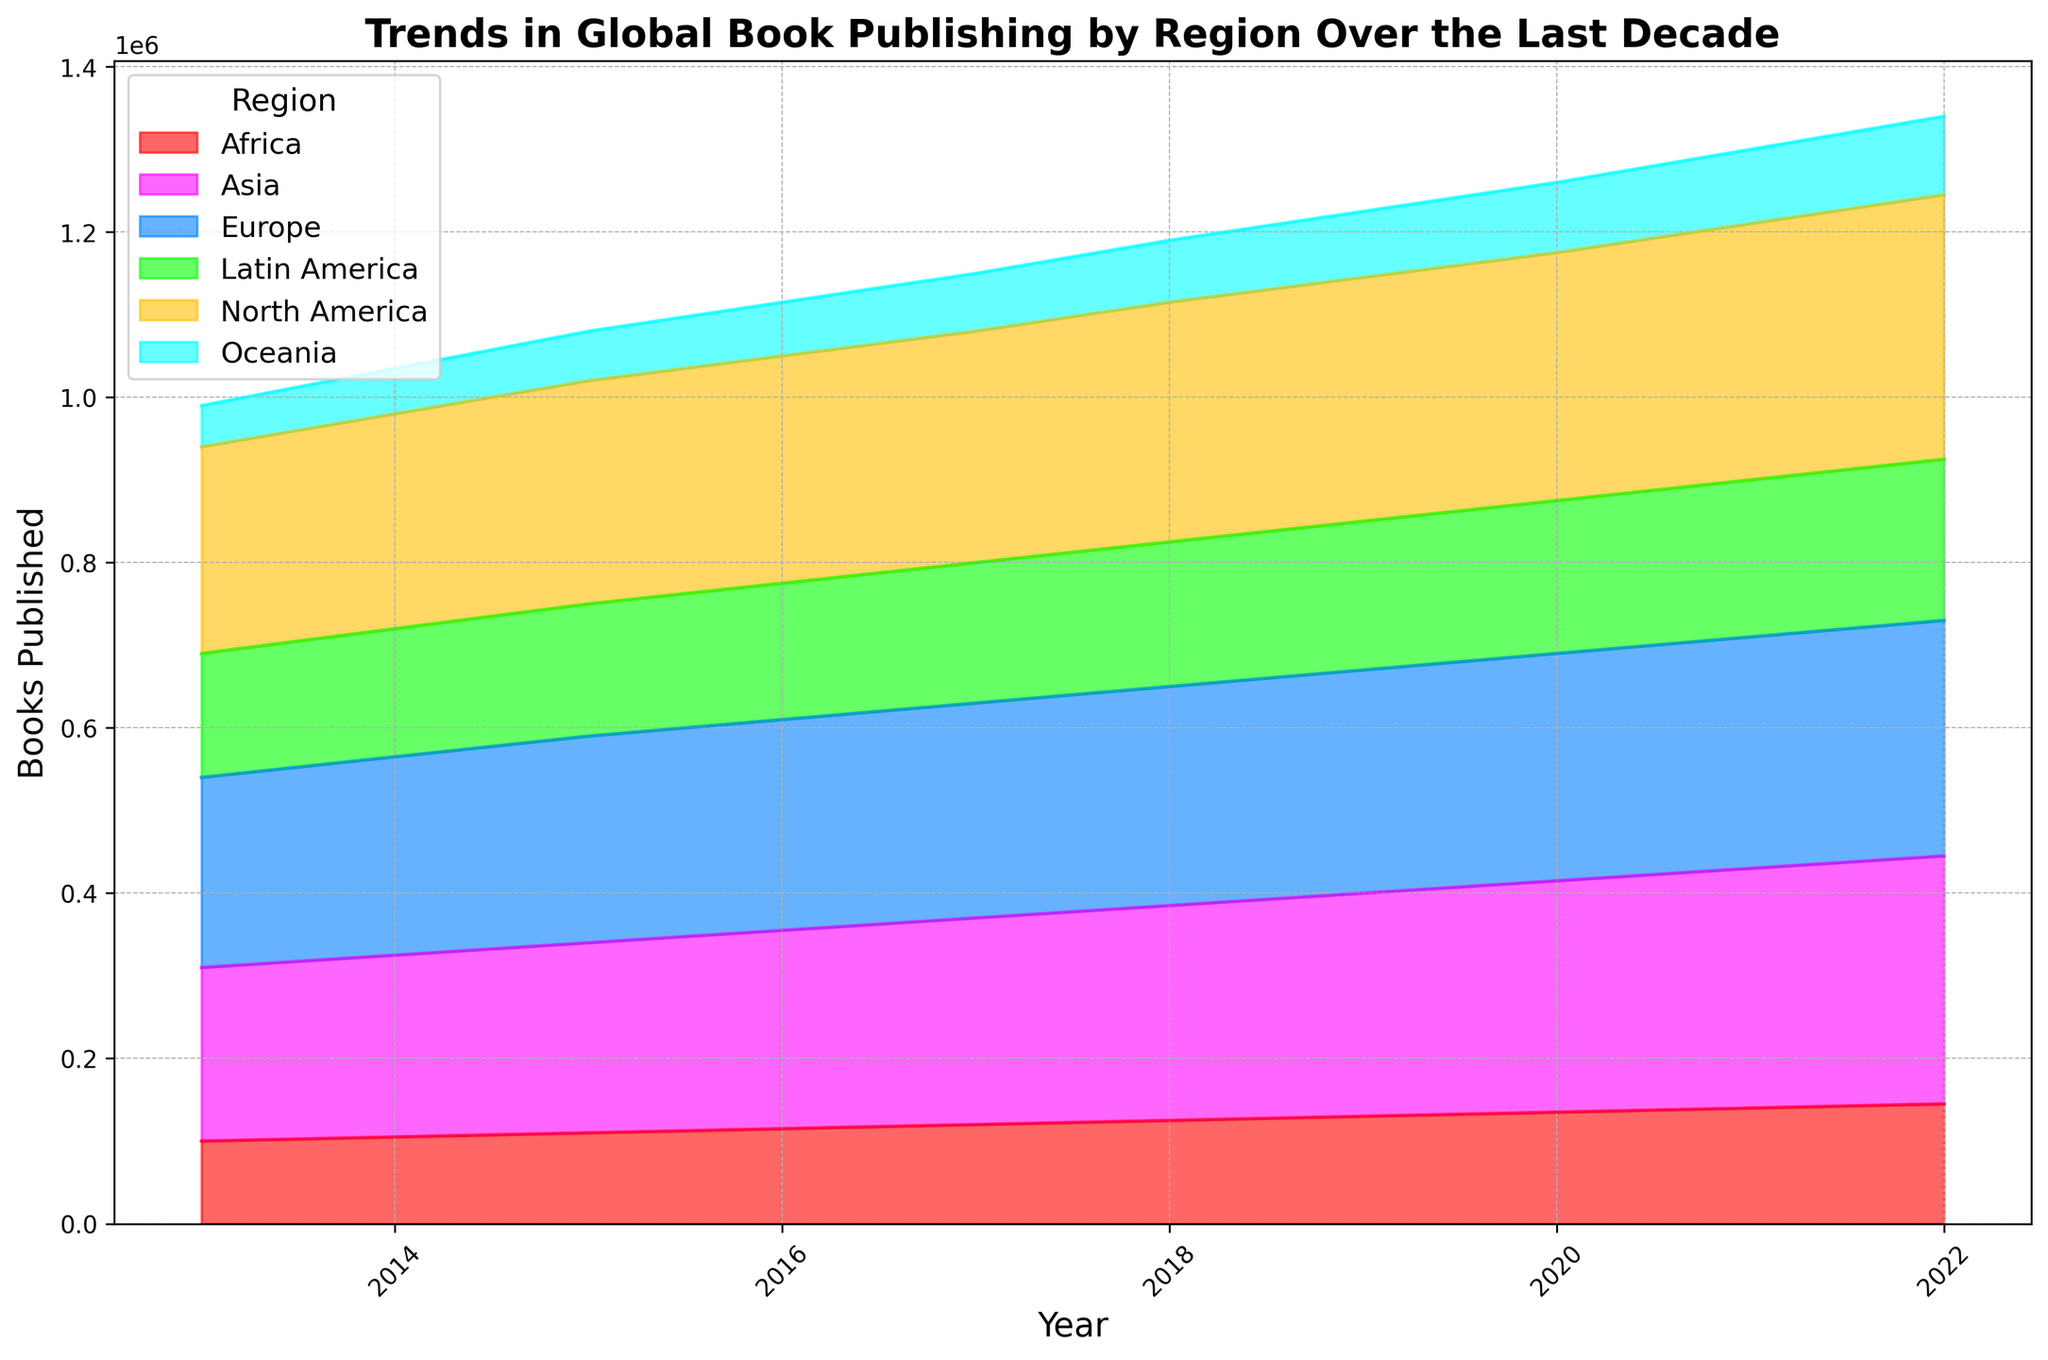Which region has the highest number of books published in 2022? The year 2022 shows the highest shaded area for Asia, indicating it has the highest number of books published.
Answer: Asia Compare the trends for North America and Europe over the last decade. Which region experienced a greater increase in book publications? North America started at 250,000 books in 2013 and rose to 320,000 in 2022, an increase of 70,000 books. Europe started at 230,000 and increased to 285,000 in the same period, an increase of 55,000 books.
Answer: North America What is the combined total of books published by Latin America and Oceania in 2022? Latin America published 195,000 books and Oceania published 95,000 books in 2022. Combined, that’s 195,000 + 95,000 = 290,000 books.
Answer: 290,000 In which year did Africa publish more books than Oceania for the first time? In the chart, Africa’s line first surpasses Oceania’s in 2018, where Africa published 125,000 books and Oceania published 75,000 books.
Answer: 2018 What is the difference in the number of books published between the regions with the most and least book publications in 2022? In 2022, Asia published 300,000 books (most) and Oceania published 95,000 books (least). The difference is 300,000 - 95,000 = 205,000 books.
Answer: 205,000 How has the number of books published in North America changed from 2013 to 2022? In 2013, North America published 250,000 books, and in 2022, it published 320,000 books. The change is 320,000 - 250,000 = 70,000 books.
Answer: Increased by 70,000 Which region shows a consistent upward trend in book publications without any decline throughout the decade? Asia shows a consistent upward trend each year from 2013 to 2022 without any decline in book publications.
Answer: Asia 